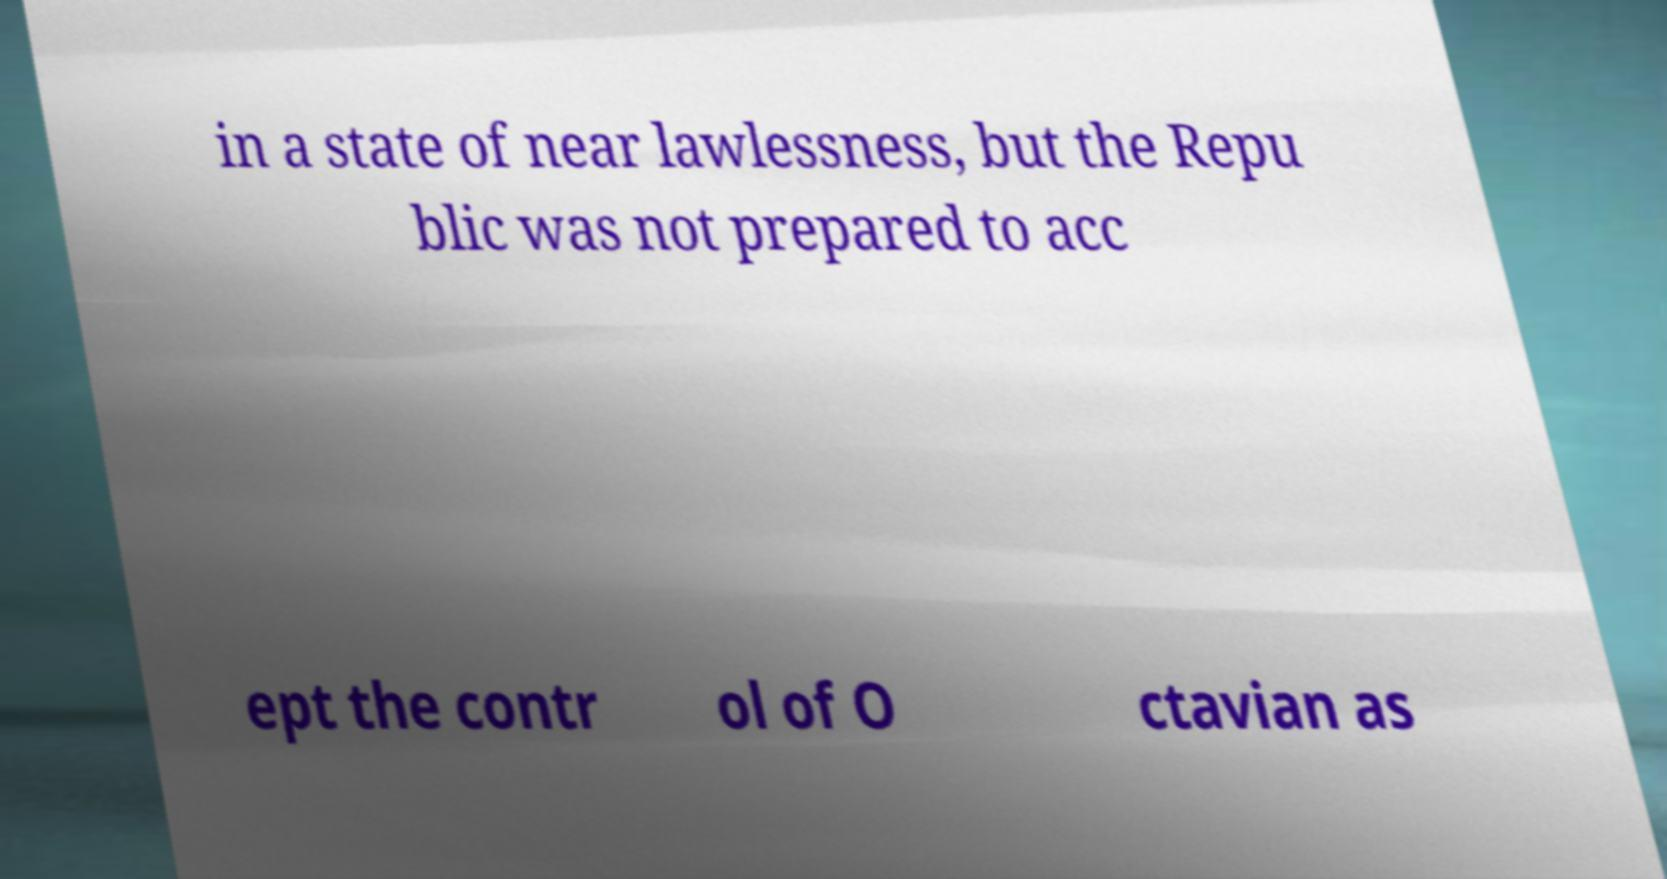Please read and relay the text visible in this image. What does it say? in a state of near lawlessness, but the Repu blic was not prepared to acc ept the contr ol of O ctavian as 